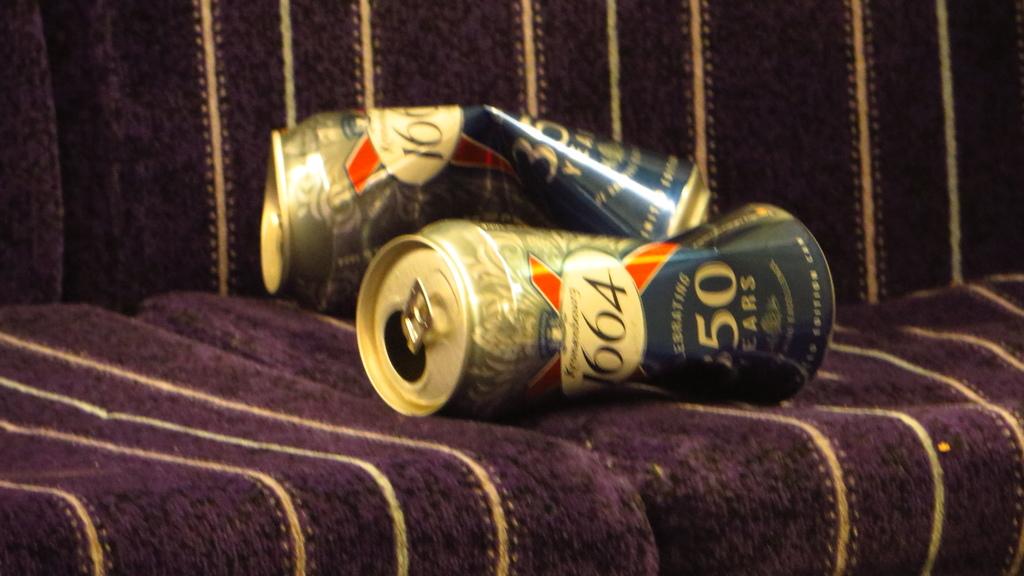What is the brand of beer?
Provide a short and direct response. 1664. 